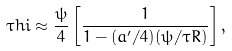<formula> <loc_0><loc_0><loc_500><loc_500>\tau h i \approx \frac { \psi } { 4 } \left [ \frac { 1 } { 1 - ( a ^ { \prime } / 4 ) ( \psi / \tau R ) } \right ] ,</formula> 